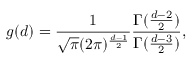<formula> <loc_0><loc_0><loc_500><loc_500>g ( d ) = \frac { 1 } { \sqrt { \pi } ( 2 \pi ) ^ { \frac { d - 1 } { 2 } } } \frac { \Gamma ( \frac { d - 2 } { 2 } ) } { \Gamma ( \frac { d - 3 } { 2 } ) } ,</formula> 